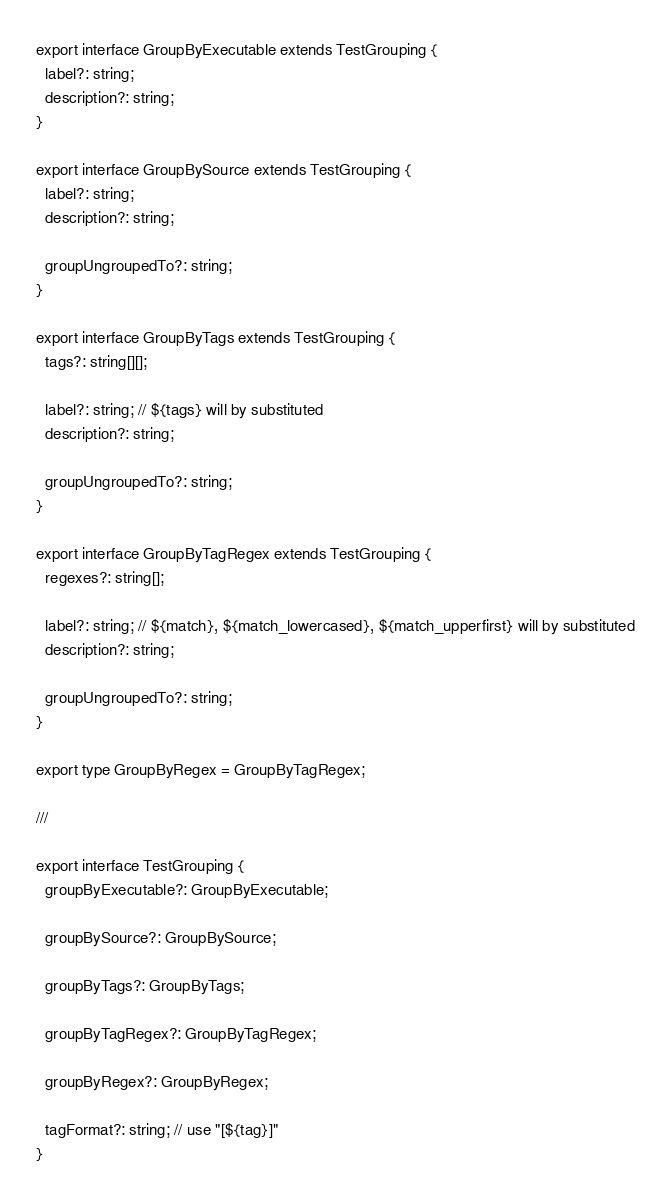<code> <loc_0><loc_0><loc_500><loc_500><_TypeScript_>export interface GroupByExecutable extends TestGrouping {
  label?: string;
  description?: string;
}

export interface GroupBySource extends TestGrouping {
  label?: string;
  description?: string;

  groupUngroupedTo?: string;
}

export interface GroupByTags extends TestGrouping {
  tags?: string[][];

  label?: string; // ${tags} will by substituted
  description?: string;

  groupUngroupedTo?: string;
}

export interface GroupByTagRegex extends TestGrouping {
  regexes?: string[];

  label?: string; // ${match}, ${match_lowercased}, ${match_upperfirst} will by substituted
  description?: string;

  groupUngroupedTo?: string;
}

export type GroupByRegex = GroupByTagRegex;

///

export interface TestGrouping {
  groupByExecutable?: GroupByExecutable;

  groupBySource?: GroupBySource;

  groupByTags?: GroupByTags;

  groupByTagRegex?: GroupByTagRegex;

  groupByRegex?: GroupByRegex;

  tagFormat?: string; // use "[${tag}]"
}
</code> 